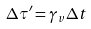<formula> <loc_0><loc_0><loc_500><loc_500>\Delta \tau ^ { \prime } = \gamma _ { v } \Delta t</formula> 